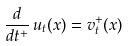Convert formula to latex. <formula><loc_0><loc_0><loc_500><loc_500>\frac { d } { d t ^ { + } } \, u _ { t } ( x ) = v _ { t } ^ { + } ( x )</formula> 